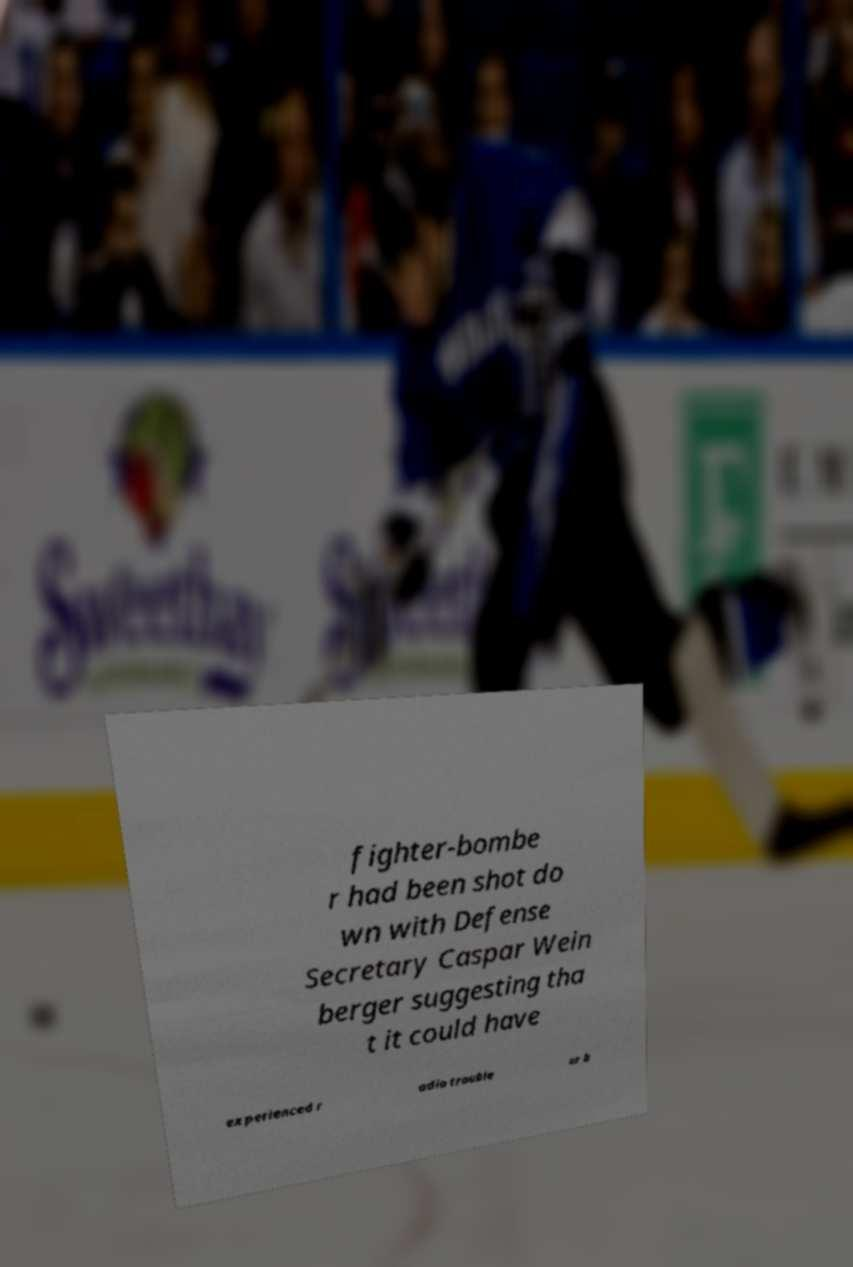There's text embedded in this image that I need extracted. Can you transcribe it verbatim? fighter-bombe r had been shot do wn with Defense Secretary Caspar Wein berger suggesting tha t it could have experienced r adio trouble or b 